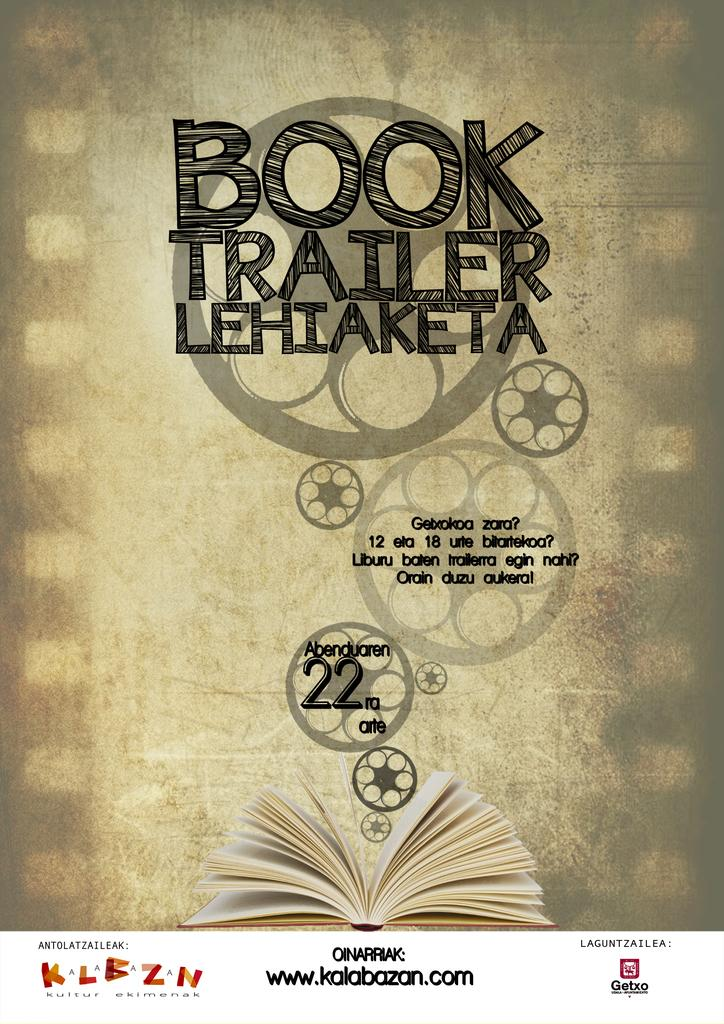<image>
Write a terse but informative summary of the picture. A poster has a film theme and is titled "Book Trailer Lehiaketa". 